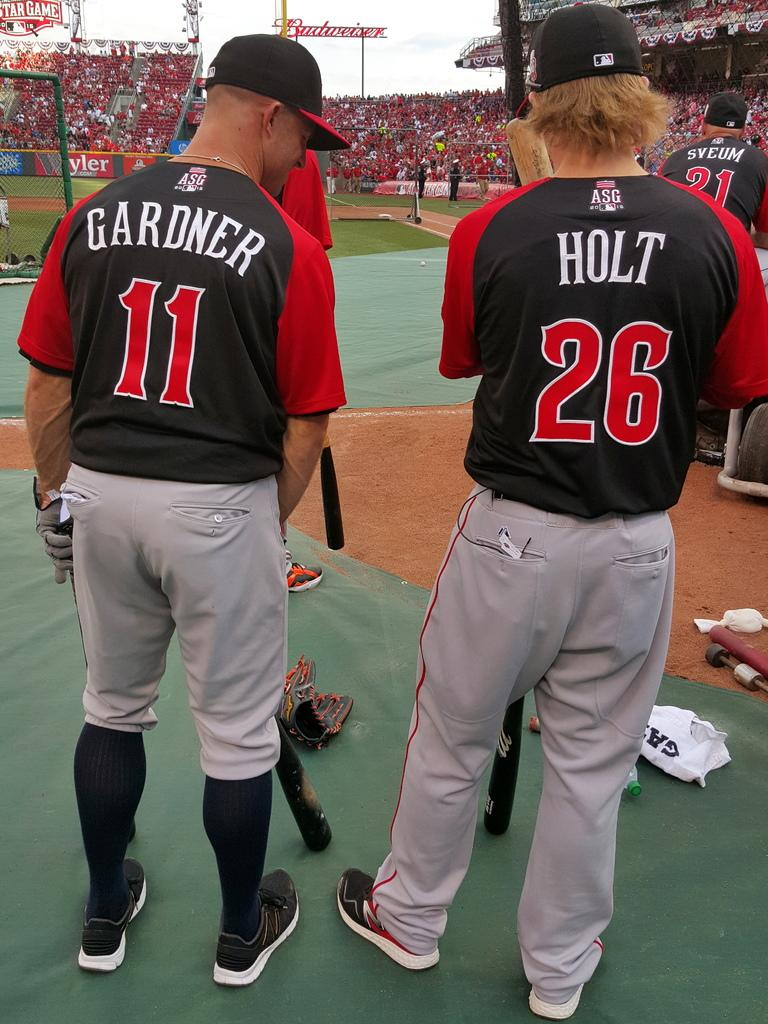<image>
Present a compact description of the photo's key features. Holt and Gardner stand next to each other and look at the equipment on the floor. 